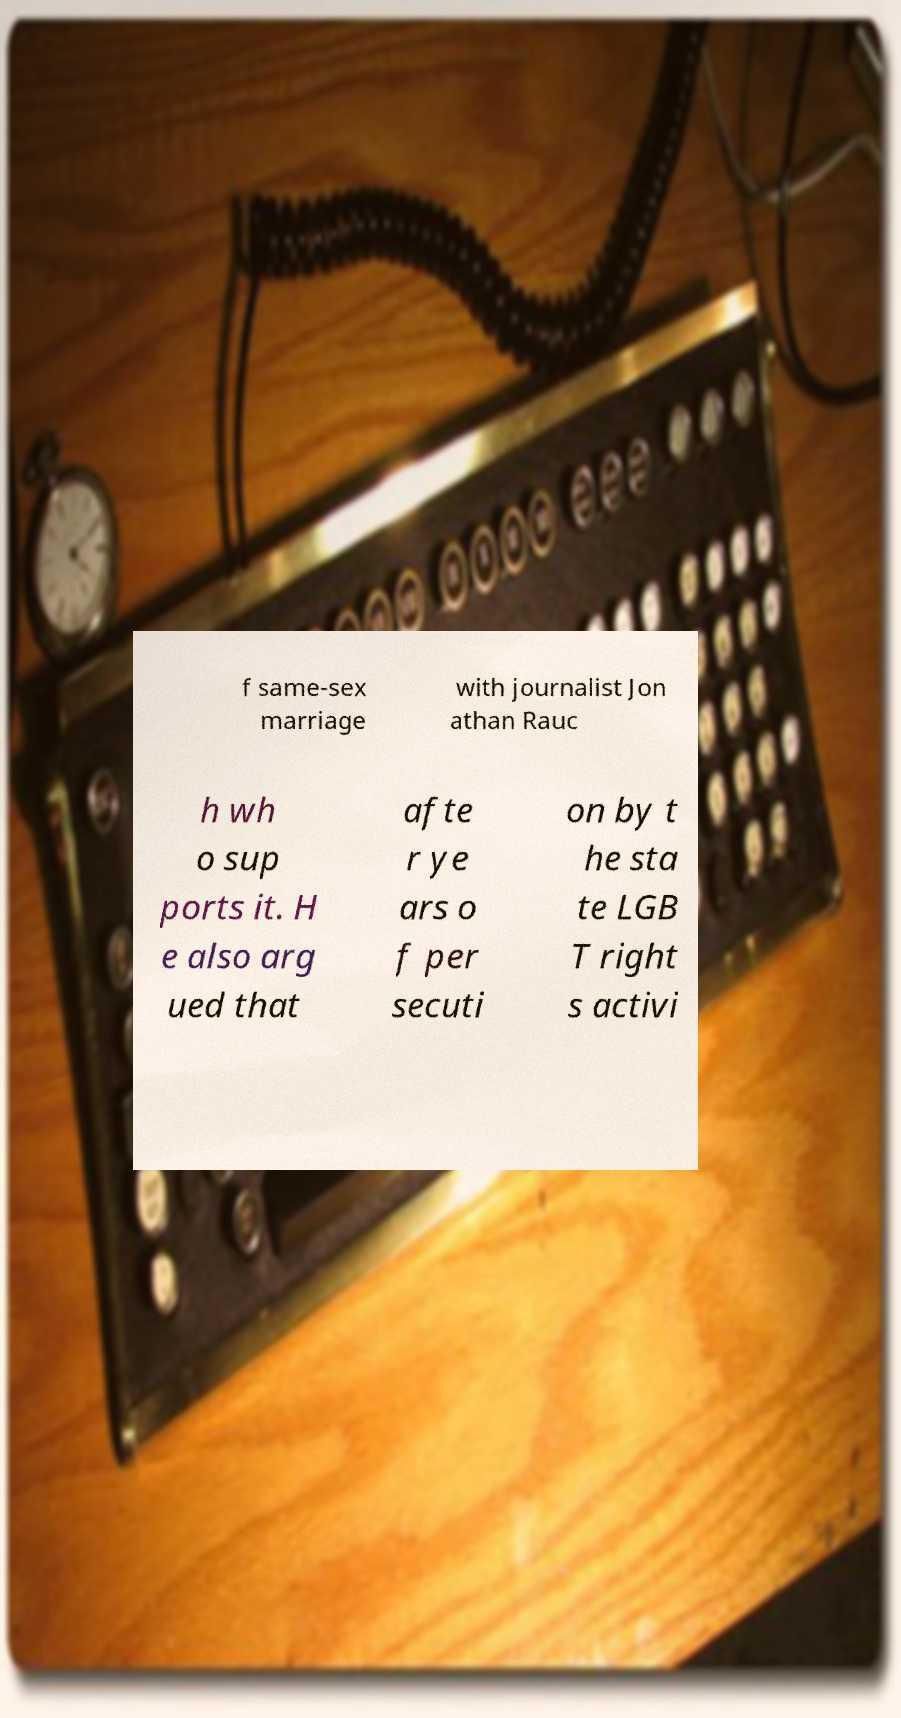Can you accurately transcribe the text from the provided image for me? f same-sex marriage with journalist Jon athan Rauc h wh o sup ports it. H e also arg ued that afte r ye ars o f per secuti on by t he sta te LGB T right s activi 